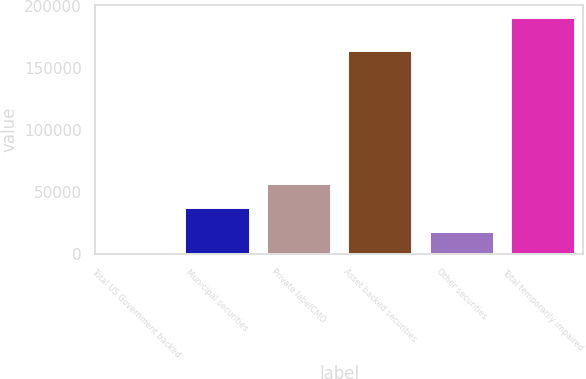Convert chart to OTSL. <chart><loc_0><loc_0><loc_500><loc_500><bar_chart><fcel>Total US Government backed<fcel>Municipal securities<fcel>Private labelCMO<fcel>Asset backed securities<fcel>Other securities<fcel>Total temporarily impaired<nl><fcel>8<fcel>38338<fcel>57503<fcel>164634<fcel>19173<fcel>191658<nl></chart> 